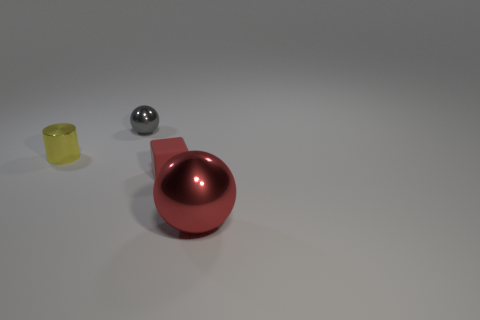What is the mood or atmosphere conveyed by the arrangement of these objects? The atmosphere of the image feels quite minimalistic and orderly, with a clean background and ample space between objects. The lighting and shadows create a serene, almost gallery-like presentation, which is very neutral and leaves the interpretation open to the viewer. 